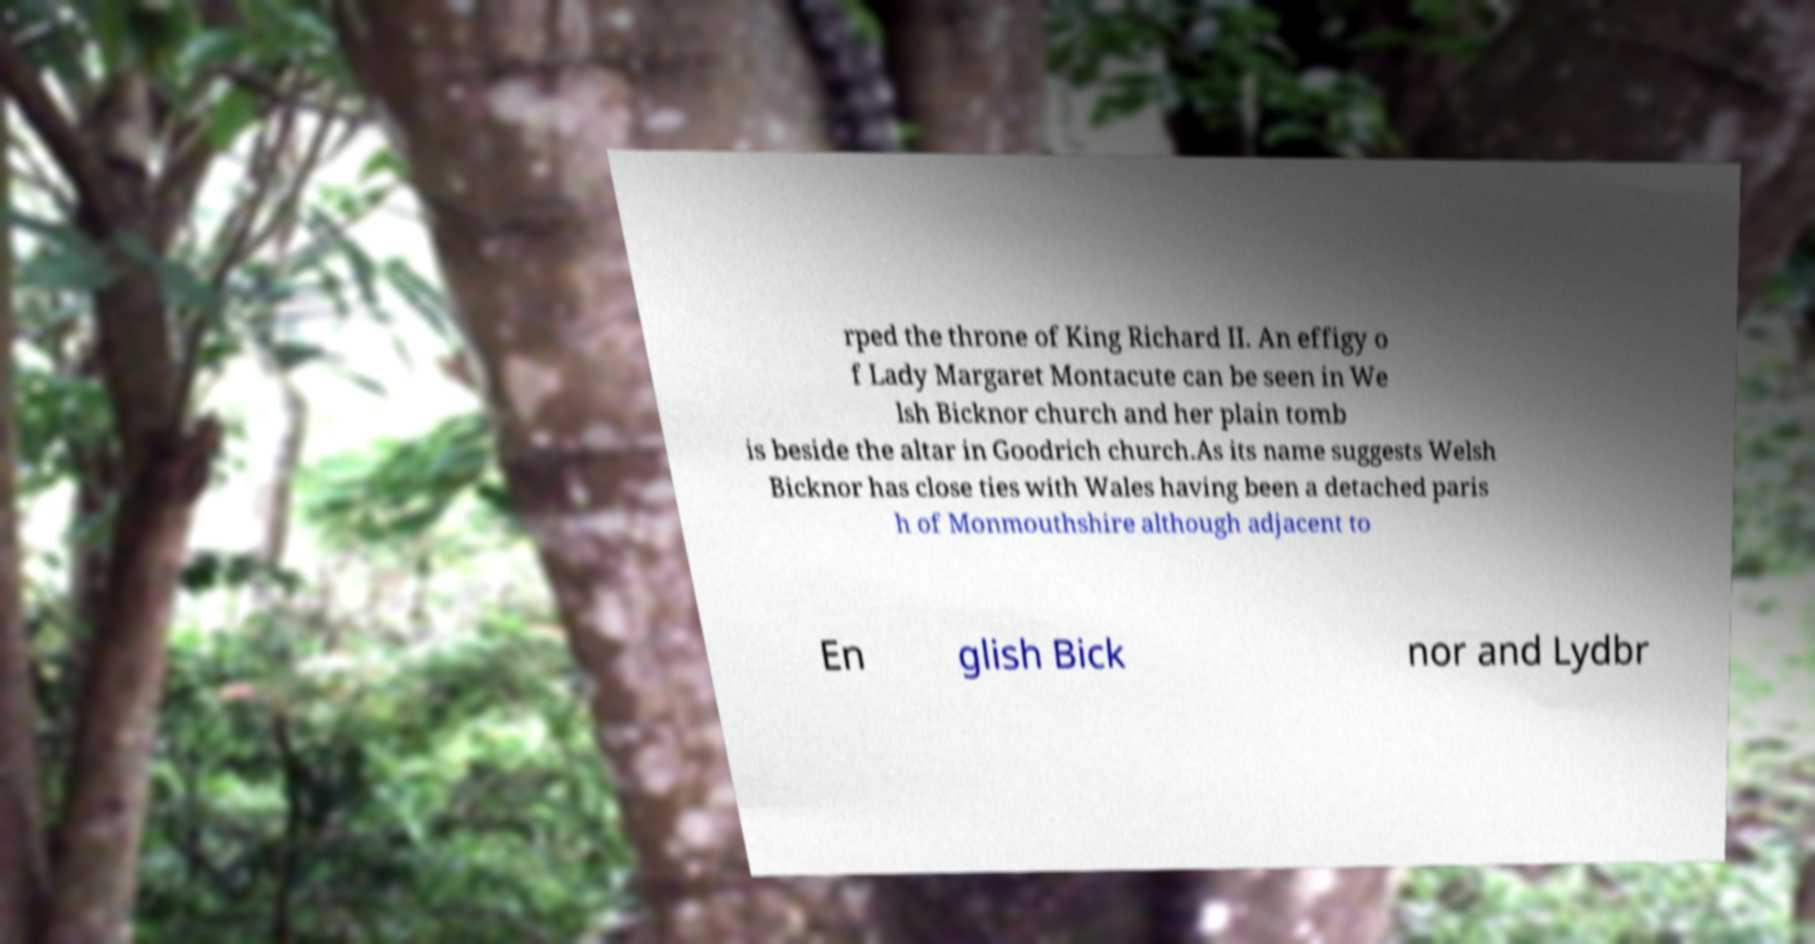For documentation purposes, I need the text within this image transcribed. Could you provide that? rped the throne of King Richard II. An effigy o f Lady Margaret Montacute can be seen in We lsh Bicknor church and her plain tomb is beside the altar in Goodrich church.As its name suggests Welsh Bicknor has close ties with Wales having been a detached paris h of Monmouthshire although adjacent to En glish Bick nor and Lydbr 